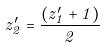<formula> <loc_0><loc_0><loc_500><loc_500>z _ { 2 } ^ { \prime } = \frac { ( z _ { 1 } ^ { \prime } + 1 ) } { 2 }</formula> 